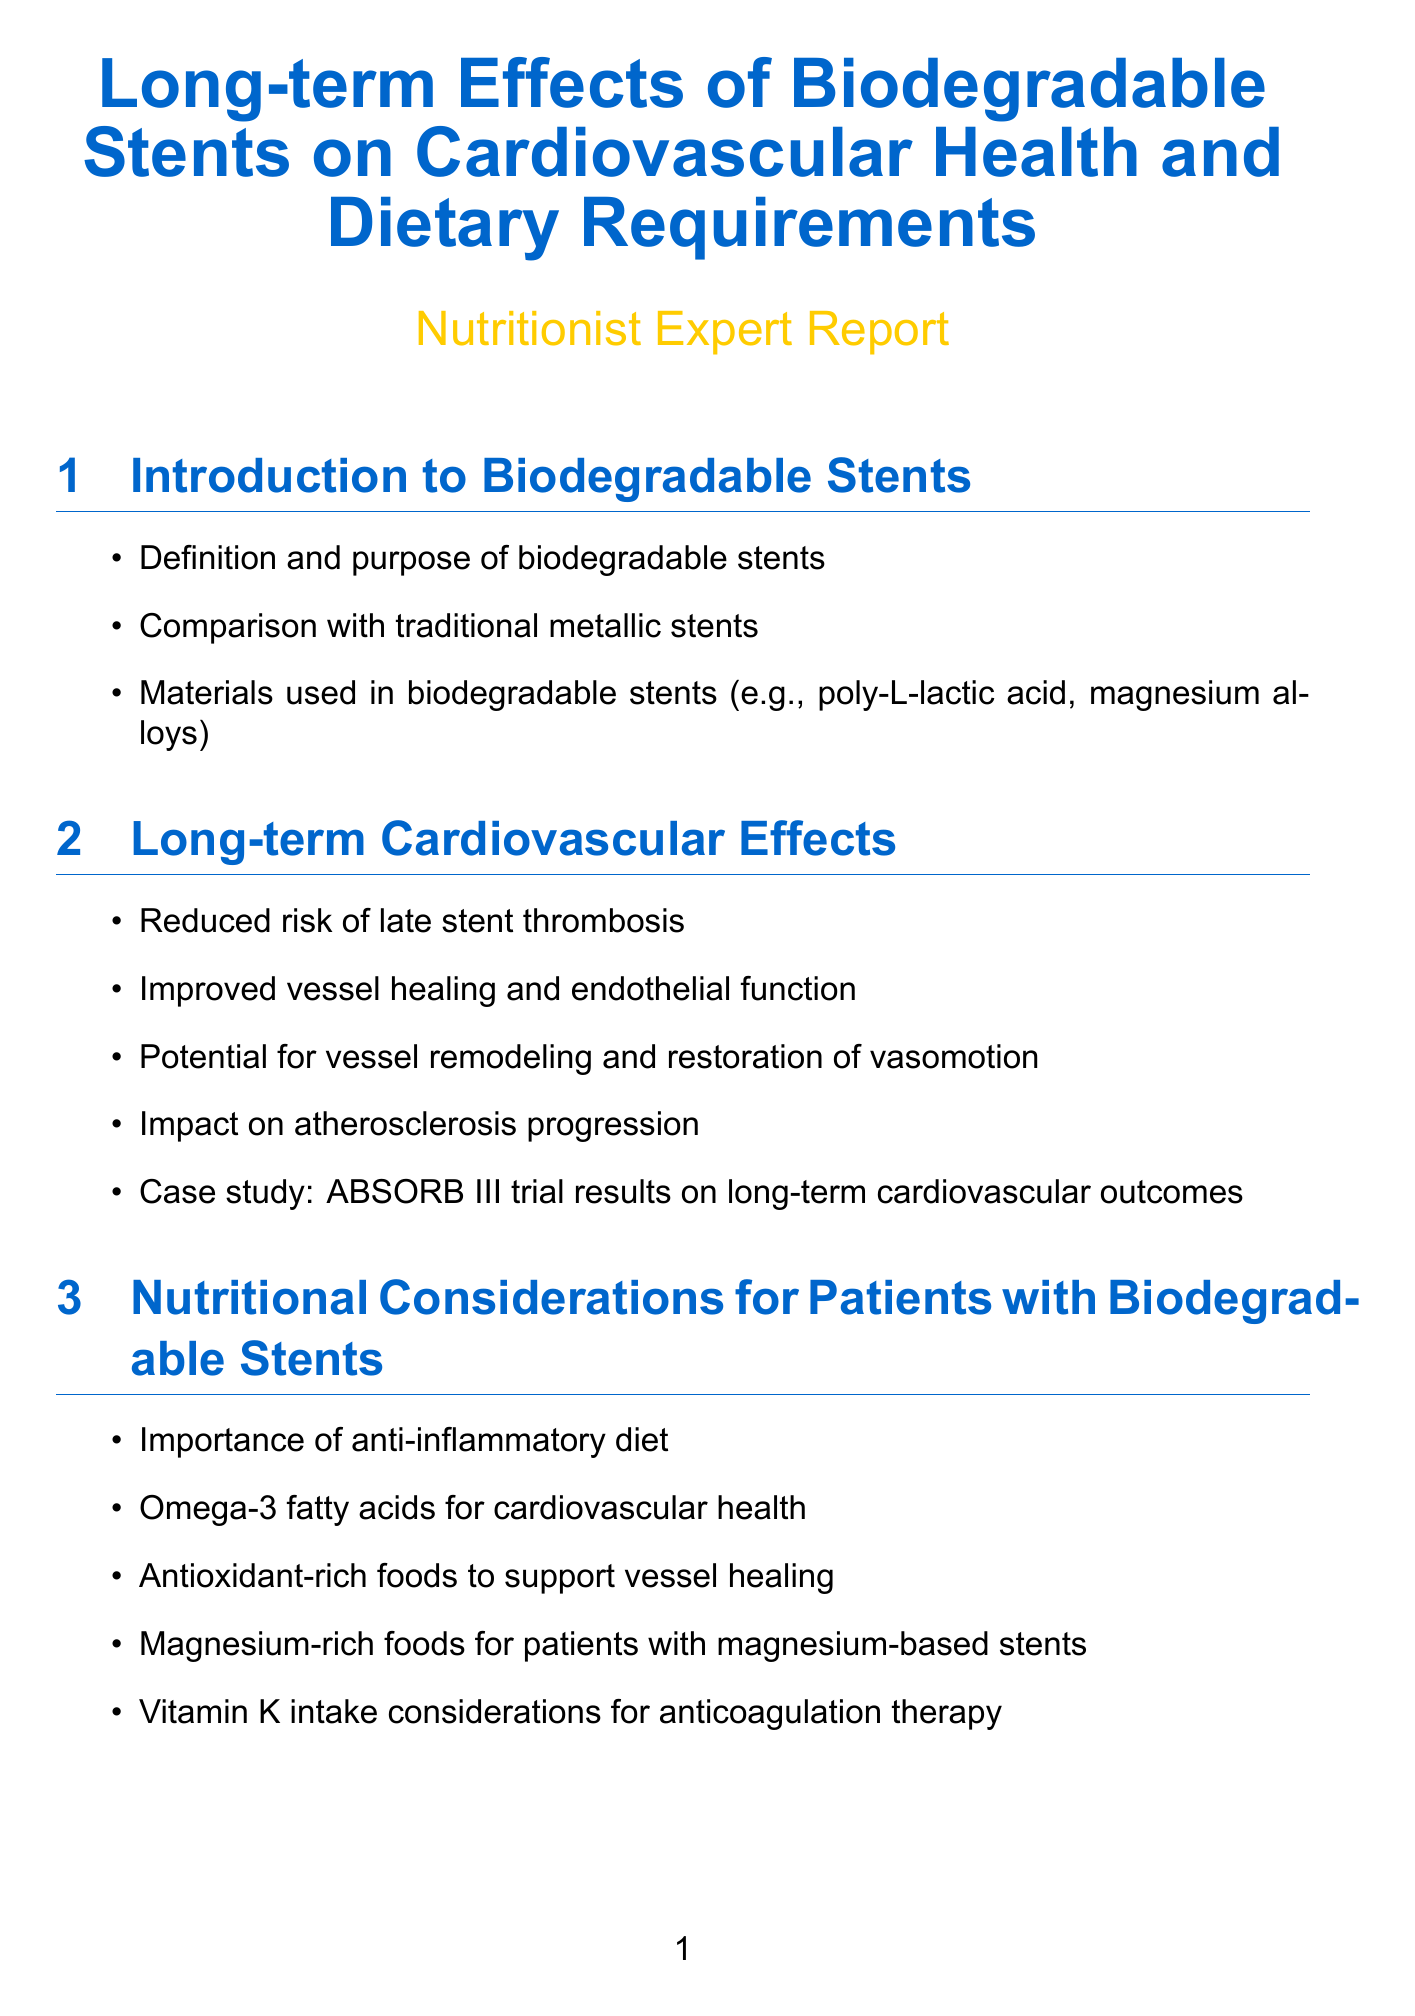What materials are used in biodegradable stents? The document lists materials such as poly-L-lactic acid and magnesium alloys under the introduction section.
Answer: poly-L-lactic acid, magnesium alloys What are the potential long-term cardiovascular outcomes mentioned? The section on long-term cardiovascular effects discusses outcomes like reduced risk of late stent thrombosis and improved vessel healing.
Answer: Reduced risk of late stent thrombosis, improved vessel healing What nutritional component is emphasized for cardiovascular health? The nutritional considerations section highlights the importance of omega-3 fatty acids for cardiovascular health.
Answer: Omega-3 fatty acids Which vitamins are important for tissue repair as per the dietary requirements? The dietary requirements section mentions protein and specific vitamins for tissue repair, particularly emphasizing protein needs.
Answer: Protein What study is referenced regarding nutritional outcomes in stent patients? The case studies section references the RESTORE multicenter trial related to nutritional outcomes in patients with bioresorbable scaffolds.
Answer: RESTORE multicenter trial What is one dietary recommendation for patients with magnesium-based stents? The nutritional considerations section recommends magnesium-rich foods for patients with magnesium-based stents.
Answer: Magnesium-rich foods How does the document suggest tracking stent degradation? The monitoring and follow-up section mentions biomarkers as a way to track stent degradation and vessel health.
Answer: Biomarkers What is the overarching theme of the conclusion section? The conclusion and recommendations section summarizes the importance of key dietary guidelines and interdisciplinary approaches.
Answer: Key dietary guidelines, interdisciplinary approach 